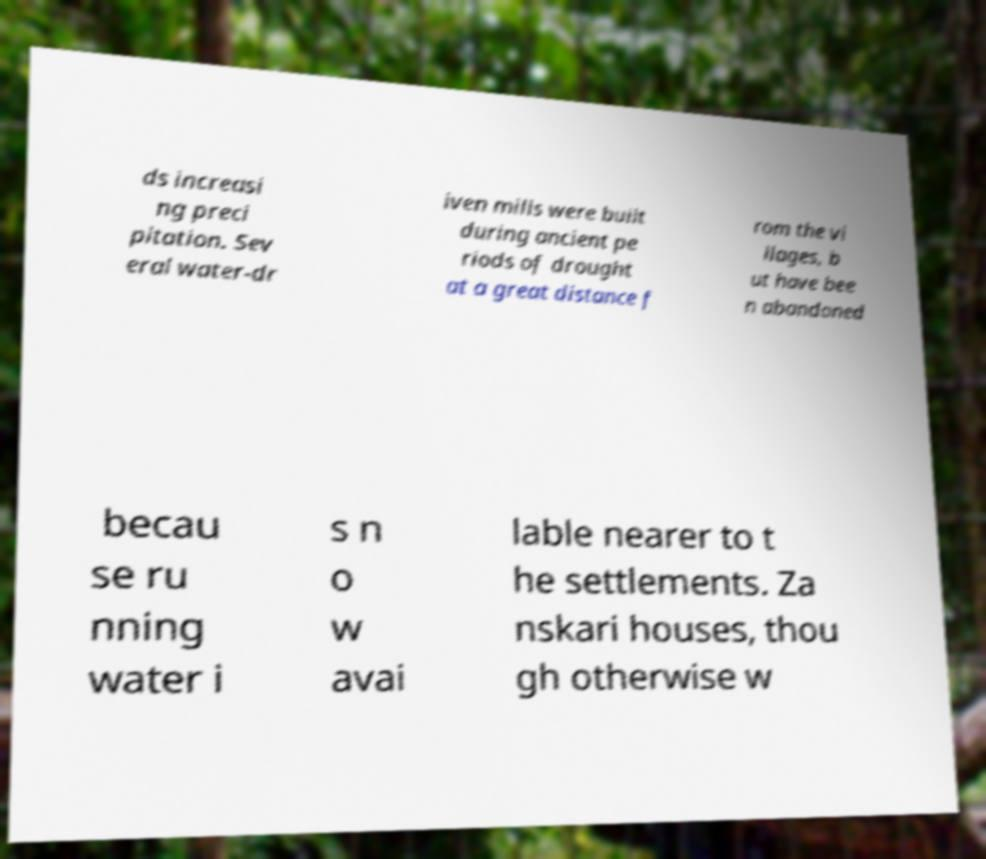There's text embedded in this image that I need extracted. Can you transcribe it verbatim? ds increasi ng preci pitation. Sev eral water-dr iven mills were built during ancient pe riods of drought at a great distance f rom the vi llages, b ut have bee n abandoned becau se ru nning water i s n o w avai lable nearer to t he settlements. Za nskari houses, thou gh otherwise w 